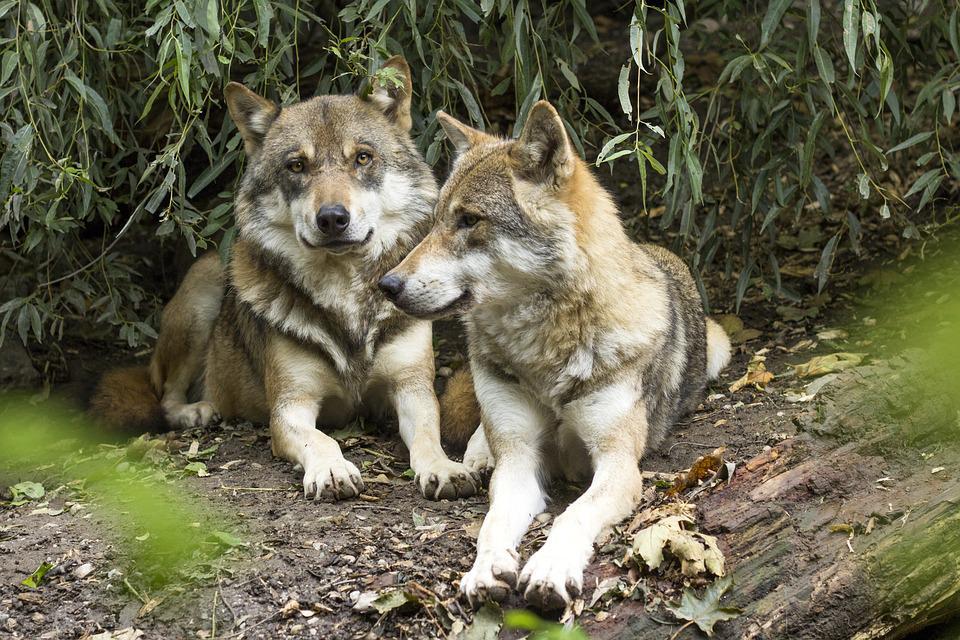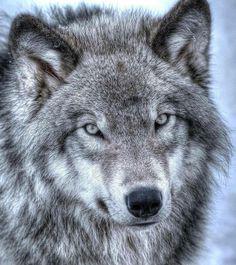The first image is the image on the left, the second image is the image on the right. Given the left and right images, does the statement "There are two wolves snuggling in the right image." hold true? Answer yes or no. No. 